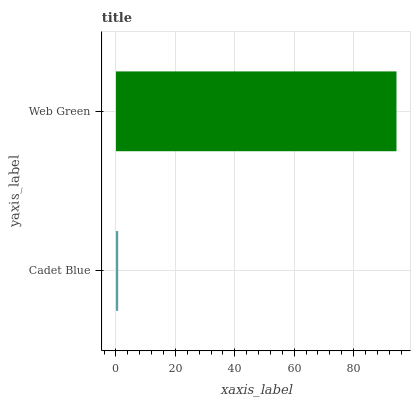Is Cadet Blue the minimum?
Answer yes or no. Yes. Is Web Green the maximum?
Answer yes or no. Yes. Is Web Green the minimum?
Answer yes or no. No. Is Web Green greater than Cadet Blue?
Answer yes or no. Yes. Is Cadet Blue less than Web Green?
Answer yes or no. Yes. Is Cadet Blue greater than Web Green?
Answer yes or no. No. Is Web Green less than Cadet Blue?
Answer yes or no. No. Is Web Green the high median?
Answer yes or no. Yes. Is Cadet Blue the low median?
Answer yes or no. Yes. Is Cadet Blue the high median?
Answer yes or no. No. Is Web Green the low median?
Answer yes or no. No. 